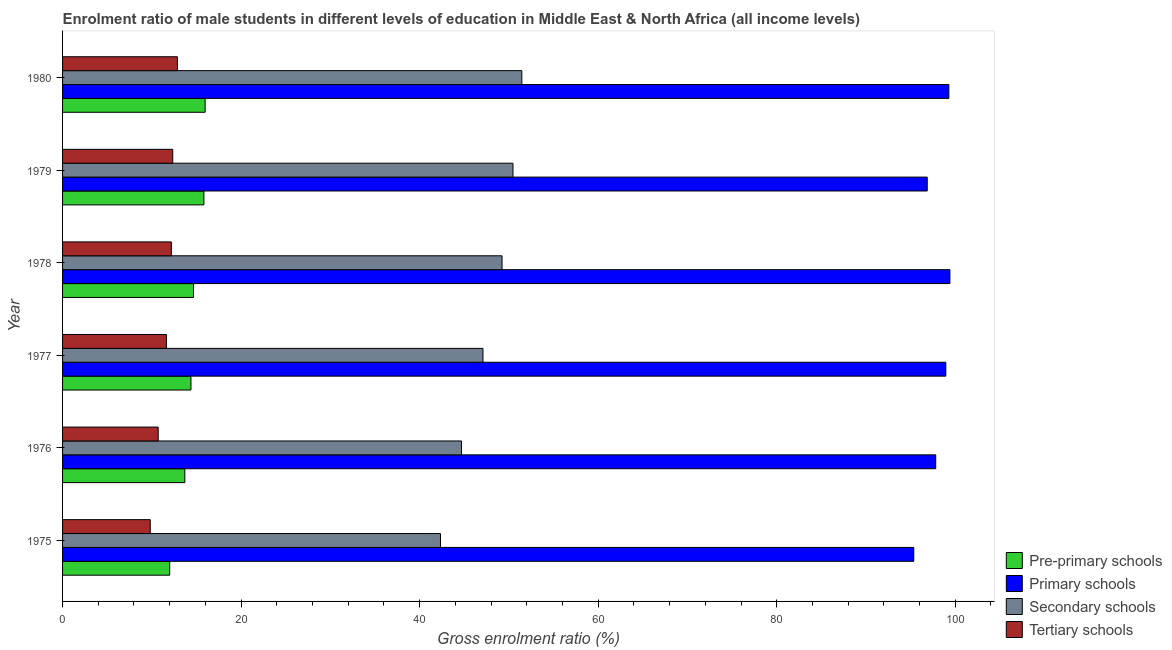How many groups of bars are there?
Ensure brevity in your answer.  6. How many bars are there on the 2nd tick from the bottom?
Offer a terse response. 4. What is the gross enrolment ratio(female) in secondary schools in 1975?
Offer a very short reply. 42.33. Across all years, what is the maximum gross enrolment ratio(female) in pre-primary schools?
Your response must be concise. 15.97. Across all years, what is the minimum gross enrolment ratio(female) in primary schools?
Your answer should be compact. 95.35. In which year was the gross enrolment ratio(female) in pre-primary schools maximum?
Your response must be concise. 1980. In which year was the gross enrolment ratio(female) in tertiary schools minimum?
Keep it short and to the point. 1975. What is the total gross enrolment ratio(female) in pre-primary schools in the graph?
Ensure brevity in your answer.  86.55. What is the difference between the gross enrolment ratio(female) in primary schools in 1977 and that in 1980?
Offer a very short reply. -0.34. What is the difference between the gross enrolment ratio(female) in pre-primary schools in 1980 and the gross enrolment ratio(female) in tertiary schools in 1977?
Keep it short and to the point. 4.34. What is the average gross enrolment ratio(female) in tertiary schools per year?
Your response must be concise. 11.59. In the year 1979, what is the difference between the gross enrolment ratio(female) in primary schools and gross enrolment ratio(female) in pre-primary schools?
Your answer should be compact. 81.03. In how many years, is the gross enrolment ratio(female) in pre-primary schools greater than 28 %?
Provide a short and direct response. 0. What is the ratio of the gross enrolment ratio(female) in pre-primary schools in 1978 to that in 1980?
Give a very brief answer. 0.92. What is the difference between the highest and the second highest gross enrolment ratio(female) in primary schools?
Keep it short and to the point. 0.12. What is the difference between the highest and the lowest gross enrolment ratio(female) in pre-primary schools?
Your answer should be very brief. 3.97. Is the sum of the gross enrolment ratio(female) in tertiary schools in 1977 and 1979 greater than the maximum gross enrolment ratio(female) in pre-primary schools across all years?
Your response must be concise. Yes. Is it the case that in every year, the sum of the gross enrolment ratio(female) in pre-primary schools and gross enrolment ratio(female) in tertiary schools is greater than the sum of gross enrolment ratio(female) in primary schools and gross enrolment ratio(female) in secondary schools?
Your answer should be compact. No. What does the 1st bar from the top in 1975 represents?
Ensure brevity in your answer.  Tertiary schools. What does the 2nd bar from the bottom in 1978 represents?
Give a very brief answer. Primary schools. Is it the case that in every year, the sum of the gross enrolment ratio(female) in pre-primary schools and gross enrolment ratio(female) in primary schools is greater than the gross enrolment ratio(female) in secondary schools?
Ensure brevity in your answer.  Yes. Are the values on the major ticks of X-axis written in scientific E-notation?
Make the answer very short. No. Does the graph contain any zero values?
Give a very brief answer. No. Does the graph contain grids?
Provide a short and direct response. No. How are the legend labels stacked?
Provide a short and direct response. Vertical. What is the title of the graph?
Keep it short and to the point. Enrolment ratio of male students in different levels of education in Middle East & North Africa (all income levels). Does "Switzerland" appear as one of the legend labels in the graph?
Your answer should be compact. No. What is the label or title of the X-axis?
Ensure brevity in your answer.  Gross enrolment ratio (%). What is the label or title of the Y-axis?
Ensure brevity in your answer.  Year. What is the Gross enrolment ratio (%) of Pre-primary schools in 1975?
Your answer should be very brief. 12. What is the Gross enrolment ratio (%) in Primary schools in 1975?
Provide a short and direct response. 95.35. What is the Gross enrolment ratio (%) of Secondary schools in 1975?
Your answer should be very brief. 42.33. What is the Gross enrolment ratio (%) in Tertiary schools in 1975?
Ensure brevity in your answer.  9.82. What is the Gross enrolment ratio (%) of Pre-primary schools in 1976?
Your response must be concise. 13.69. What is the Gross enrolment ratio (%) of Primary schools in 1976?
Ensure brevity in your answer.  97.81. What is the Gross enrolment ratio (%) of Secondary schools in 1976?
Make the answer very short. 44.68. What is the Gross enrolment ratio (%) of Tertiary schools in 1976?
Ensure brevity in your answer.  10.71. What is the Gross enrolment ratio (%) of Pre-primary schools in 1977?
Your answer should be very brief. 14.38. What is the Gross enrolment ratio (%) of Primary schools in 1977?
Make the answer very short. 98.94. What is the Gross enrolment ratio (%) in Secondary schools in 1977?
Your response must be concise. 47.09. What is the Gross enrolment ratio (%) in Tertiary schools in 1977?
Give a very brief answer. 11.63. What is the Gross enrolment ratio (%) of Pre-primary schools in 1978?
Provide a short and direct response. 14.67. What is the Gross enrolment ratio (%) in Primary schools in 1978?
Your response must be concise. 99.4. What is the Gross enrolment ratio (%) in Secondary schools in 1978?
Provide a short and direct response. 49.23. What is the Gross enrolment ratio (%) in Tertiary schools in 1978?
Your response must be concise. 12.19. What is the Gross enrolment ratio (%) in Pre-primary schools in 1979?
Offer a very short reply. 15.83. What is the Gross enrolment ratio (%) of Primary schools in 1979?
Provide a short and direct response. 96.86. What is the Gross enrolment ratio (%) in Secondary schools in 1979?
Give a very brief answer. 50.45. What is the Gross enrolment ratio (%) of Tertiary schools in 1979?
Offer a very short reply. 12.34. What is the Gross enrolment ratio (%) in Pre-primary schools in 1980?
Make the answer very short. 15.97. What is the Gross enrolment ratio (%) in Primary schools in 1980?
Offer a very short reply. 99.28. What is the Gross enrolment ratio (%) of Secondary schools in 1980?
Provide a succinct answer. 51.45. What is the Gross enrolment ratio (%) of Tertiary schools in 1980?
Offer a very short reply. 12.86. Across all years, what is the maximum Gross enrolment ratio (%) of Pre-primary schools?
Ensure brevity in your answer.  15.97. Across all years, what is the maximum Gross enrolment ratio (%) of Primary schools?
Offer a very short reply. 99.4. Across all years, what is the maximum Gross enrolment ratio (%) in Secondary schools?
Your response must be concise. 51.45. Across all years, what is the maximum Gross enrolment ratio (%) in Tertiary schools?
Ensure brevity in your answer.  12.86. Across all years, what is the minimum Gross enrolment ratio (%) in Pre-primary schools?
Your response must be concise. 12. Across all years, what is the minimum Gross enrolment ratio (%) of Primary schools?
Your response must be concise. 95.35. Across all years, what is the minimum Gross enrolment ratio (%) of Secondary schools?
Provide a succinct answer. 42.33. Across all years, what is the minimum Gross enrolment ratio (%) in Tertiary schools?
Your response must be concise. 9.82. What is the total Gross enrolment ratio (%) of Pre-primary schools in the graph?
Your response must be concise. 86.55. What is the total Gross enrolment ratio (%) of Primary schools in the graph?
Keep it short and to the point. 587.64. What is the total Gross enrolment ratio (%) in Secondary schools in the graph?
Provide a succinct answer. 285.24. What is the total Gross enrolment ratio (%) in Tertiary schools in the graph?
Your response must be concise. 69.56. What is the difference between the Gross enrolment ratio (%) in Pre-primary schools in 1975 and that in 1976?
Your answer should be very brief. -1.69. What is the difference between the Gross enrolment ratio (%) of Primary schools in 1975 and that in 1976?
Your answer should be compact. -2.46. What is the difference between the Gross enrolment ratio (%) of Secondary schools in 1975 and that in 1976?
Your response must be concise. -2.35. What is the difference between the Gross enrolment ratio (%) in Tertiary schools in 1975 and that in 1976?
Provide a succinct answer. -0.89. What is the difference between the Gross enrolment ratio (%) in Pre-primary schools in 1975 and that in 1977?
Your answer should be compact. -2.38. What is the difference between the Gross enrolment ratio (%) in Primary schools in 1975 and that in 1977?
Provide a short and direct response. -3.59. What is the difference between the Gross enrolment ratio (%) of Secondary schools in 1975 and that in 1977?
Provide a succinct answer. -4.76. What is the difference between the Gross enrolment ratio (%) of Tertiary schools in 1975 and that in 1977?
Provide a short and direct response. -1.81. What is the difference between the Gross enrolment ratio (%) of Pre-primary schools in 1975 and that in 1978?
Provide a short and direct response. -2.67. What is the difference between the Gross enrolment ratio (%) of Primary schools in 1975 and that in 1978?
Make the answer very short. -4.05. What is the difference between the Gross enrolment ratio (%) in Secondary schools in 1975 and that in 1978?
Keep it short and to the point. -6.9. What is the difference between the Gross enrolment ratio (%) in Tertiary schools in 1975 and that in 1978?
Your response must be concise. -2.36. What is the difference between the Gross enrolment ratio (%) of Pre-primary schools in 1975 and that in 1979?
Keep it short and to the point. -3.83. What is the difference between the Gross enrolment ratio (%) in Primary schools in 1975 and that in 1979?
Offer a very short reply. -1.51. What is the difference between the Gross enrolment ratio (%) of Secondary schools in 1975 and that in 1979?
Your response must be concise. -8.12. What is the difference between the Gross enrolment ratio (%) in Tertiary schools in 1975 and that in 1979?
Provide a short and direct response. -2.52. What is the difference between the Gross enrolment ratio (%) of Pre-primary schools in 1975 and that in 1980?
Provide a succinct answer. -3.97. What is the difference between the Gross enrolment ratio (%) of Primary schools in 1975 and that in 1980?
Offer a terse response. -3.93. What is the difference between the Gross enrolment ratio (%) of Secondary schools in 1975 and that in 1980?
Provide a succinct answer. -9.11. What is the difference between the Gross enrolment ratio (%) of Tertiary schools in 1975 and that in 1980?
Your response must be concise. -3.04. What is the difference between the Gross enrolment ratio (%) of Pre-primary schools in 1976 and that in 1977?
Your answer should be very brief. -0.69. What is the difference between the Gross enrolment ratio (%) of Primary schools in 1976 and that in 1977?
Your answer should be compact. -1.13. What is the difference between the Gross enrolment ratio (%) of Secondary schools in 1976 and that in 1977?
Offer a very short reply. -2.41. What is the difference between the Gross enrolment ratio (%) of Tertiary schools in 1976 and that in 1977?
Your response must be concise. -0.92. What is the difference between the Gross enrolment ratio (%) in Pre-primary schools in 1976 and that in 1978?
Offer a terse response. -0.97. What is the difference between the Gross enrolment ratio (%) in Primary schools in 1976 and that in 1978?
Your response must be concise. -1.59. What is the difference between the Gross enrolment ratio (%) of Secondary schools in 1976 and that in 1978?
Your response must be concise. -4.54. What is the difference between the Gross enrolment ratio (%) of Tertiary schools in 1976 and that in 1978?
Your answer should be very brief. -1.47. What is the difference between the Gross enrolment ratio (%) in Pre-primary schools in 1976 and that in 1979?
Provide a short and direct response. -2.14. What is the difference between the Gross enrolment ratio (%) of Primary schools in 1976 and that in 1979?
Keep it short and to the point. 0.95. What is the difference between the Gross enrolment ratio (%) in Secondary schools in 1976 and that in 1979?
Offer a terse response. -5.77. What is the difference between the Gross enrolment ratio (%) of Tertiary schools in 1976 and that in 1979?
Ensure brevity in your answer.  -1.63. What is the difference between the Gross enrolment ratio (%) of Pre-primary schools in 1976 and that in 1980?
Your response must be concise. -2.28. What is the difference between the Gross enrolment ratio (%) of Primary schools in 1976 and that in 1980?
Your response must be concise. -1.47. What is the difference between the Gross enrolment ratio (%) in Secondary schools in 1976 and that in 1980?
Make the answer very short. -6.76. What is the difference between the Gross enrolment ratio (%) of Tertiary schools in 1976 and that in 1980?
Provide a short and direct response. -2.15. What is the difference between the Gross enrolment ratio (%) of Pre-primary schools in 1977 and that in 1978?
Provide a short and direct response. -0.29. What is the difference between the Gross enrolment ratio (%) of Primary schools in 1977 and that in 1978?
Your answer should be compact. -0.46. What is the difference between the Gross enrolment ratio (%) in Secondary schools in 1977 and that in 1978?
Your answer should be compact. -2.14. What is the difference between the Gross enrolment ratio (%) in Tertiary schools in 1977 and that in 1978?
Give a very brief answer. -0.56. What is the difference between the Gross enrolment ratio (%) in Pre-primary schools in 1977 and that in 1979?
Your answer should be compact. -1.45. What is the difference between the Gross enrolment ratio (%) in Primary schools in 1977 and that in 1979?
Offer a terse response. 2.08. What is the difference between the Gross enrolment ratio (%) of Secondary schools in 1977 and that in 1979?
Your answer should be very brief. -3.36. What is the difference between the Gross enrolment ratio (%) in Tertiary schools in 1977 and that in 1979?
Provide a short and direct response. -0.71. What is the difference between the Gross enrolment ratio (%) in Pre-primary schools in 1977 and that in 1980?
Provide a short and direct response. -1.59. What is the difference between the Gross enrolment ratio (%) of Primary schools in 1977 and that in 1980?
Ensure brevity in your answer.  -0.34. What is the difference between the Gross enrolment ratio (%) in Secondary schools in 1977 and that in 1980?
Provide a succinct answer. -4.35. What is the difference between the Gross enrolment ratio (%) in Tertiary schools in 1977 and that in 1980?
Your answer should be compact. -1.23. What is the difference between the Gross enrolment ratio (%) in Pre-primary schools in 1978 and that in 1979?
Your answer should be compact. -1.16. What is the difference between the Gross enrolment ratio (%) in Primary schools in 1978 and that in 1979?
Offer a terse response. 2.54. What is the difference between the Gross enrolment ratio (%) of Secondary schools in 1978 and that in 1979?
Provide a succinct answer. -1.22. What is the difference between the Gross enrolment ratio (%) in Tertiary schools in 1978 and that in 1979?
Ensure brevity in your answer.  -0.15. What is the difference between the Gross enrolment ratio (%) of Pre-primary schools in 1978 and that in 1980?
Your answer should be compact. -1.3. What is the difference between the Gross enrolment ratio (%) of Primary schools in 1978 and that in 1980?
Offer a terse response. 0.12. What is the difference between the Gross enrolment ratio (%) of Secondary schools in 1978 and that in 1980?
Make the answer very short. -2.22. What is the difference between the Gross enrolment ratio (%) of Tertiary schools in 1978 and that in 1980?
Ensure brevity in your answer.  -0.68. What is the difference between the Gross enrolment ratio (%) in Pre-primary schools in 1979 and that in 1980?
Offer a very short reply. -0.14. What is the difference between the Gross enrolment ratio (%) of Primary schools in 1979 and that in 1980?
Offer a very short reply. -2.42. What is the difference between the Gross enrolment ratio (%) of Secondary schools in 1979 and that in 1980?
Make the answer very short. -0.99. What is the difference between the Gross enrolment ratio (%) in Tertiary schools in 1979 and that in 1980?
Provide a short and direct response. -0.52. What is the difference between the Gross enrolment ratio (%) in Pre-primary schools in 1975 and the Gross enrolment ratio (%) in Primary schools in 1976?
Your answer should be very brief. -85.81. What is the difference between the Gross enrolment ratio (%) in Pre-primary schools in 1975 and the Gross enrolment ratio (%) in Secondary schools in 1976?
Make the answer very short. -32.68. What is the difference between the Gross enrolment ratio (%) in Pre-primary schools in 1975 and the Gross enrolment ratio (%) in Tertiary schools in 1976?
Provide a short and direct response. 1.29. What is the difference between the Gross enrolment ratio (%) of Primary schools in 1975 and the Gross enrolment ratio (%) of Secondary schools in 1976?
Keep it short and to the point. 50.67. What is the difference between the Gross enrolment ratio (%) in Primary schools in 1975 and the Gross enrolment ratio (%) in Tertiary schools in 1976?
Offer a terse response. 84.64. What is the difference between the Gross enrolment ratio (%) of Secondary schools in 1975 and the Gross enrolment ratio (%) of Tertiary schools in 1976?
Offer a very short reply. 31.62. What is the difference between the Gross enrolment ratio (%) in Pre-primary schools in 1975 and the Gross enrolment ratio (%) in Primary schools in 1977?
Offer a terse response. -86.94. What is the difference between the Gross enrolment ratio (%) in Pre-primary schools in 1975 and the Gross enrolment ratio (%) in Secondary schools in 1977?
Keep it short and to the point. -35.09. What is the difference between the Gross enrolment ratio (%) in Pre-primary schools in 1975 and the Gross enrolment ratio (%) in Tertiary schools in 1977?
Offer a very short reply. 0.37. What is the difference between the Gross enrolment ratio (%) of Primary schools in 1975 and the Gross enrolment ratio (%) of Secondary schools in 1977?
Your answer should be very brief. 48.26. What is the difference between the Gross enrolment ratio (%) of Primary schools in 1975 and the Gross enrolment ratio (%) of Tertiary schools in 1977?
Provide a short and direct response. 83.72. What is the difference between the Gross enrolment ratio (%) of Secondary schools in 1975 and the Gross enrolment ratio (%) of Tertiary schools in 1977?
Provide a succinct answer. 30.7. What is the difference between the Gross enrolment ratio (%) in Pre-primary schools in 1975 and the Gross enrolment ratio (%) in Primary schools in 1978?
Keep it short and to the point. -87.4. What is the difference between the Gross enrolment ratio (%) in Pre-primary schools in 1975 and the Gross enrolment ratio (%) in Secondary schools in 1978?
Your response must be concise. -37.23. What is the difference between the Gross enrolment ratio (%) in Pre-primary schools in 1975 and the Gross enrolment ratio (%) in Tertiary schools in 1978?
Your answer should be very brief. -0.19. What is the difference between the Gross enrolment ratio (%) of Primary schools in 1975 and the Gross enrolment ratio (%) of Secondary schools in 1978?
Provide a short and direct response. 46.12. What is the difference between the Gross enrolment ratio (%) of Primary schools in 1975 and the Gross enrolment ratio (%) of Tertiary schools in 1978?
Provide a succinct answer. 83.16. What is the difference between the Gross enrolment ratio (%) in Secondary schools in 1975 and the Gross enrolment ratio (%) in Tertiary schools in 1978?
Offer a very short reply. 30.15. What is the difference between the Gross enrolment ratio (%) in Pre-primary schools in 1975 and the Gross enrolment ratio (%) in Primary schools in 1979?
Your answer should be very brief. -84.86. What is the difference between the Gross enrolment ratio (%) of Pre-primary schools in 1975 and the Gross enrolment ratio (%) of Secondary schools in 1979?
Give a very brief answer. -38.45. What is the difference between the Gross enrolment ratio (%) of Pre-primary schools in 1975 and the Gross enrolment ratio (%) of Tertiary schools in 1979?
Provide a short and direct response. -0.34. What is the difference between the Gross enrolment ratio (%) in Primary schools in 1975 and the Gross enrolment ratio (%) in Secondary schools in 1979?
Offer a terse response. 44.9. What is the difference between the Gross enrolment ratio (%) of Primary schools in 1975 and the Gross enrolment ratio (%) of Tertiary schools in 1979?
Offer a terse response. 83.01. What is the difference between the Gross enrolment ratio (%) in Secondary schools in 1975 and the Gross enrolment ratio (%) in Tertiary schools in 1979?
Provide a succinct answer. 29.99. What is the difference between the Gross enrolment ratio (%) in Pre-primary schools in 1975 and the Gross enrolment ratio (%) in Primary schools in 1980?
Provide a short and direct response. -87.28. What is the difference between the Gross enrolment ratio (%) of Pre-primary schools in 1975 and the Gross enrolment ratio (%) of Secondary schools in 1980?
Ensure brevity in your answer.  -39.44. What is the difference between the Gross enrolment ratio (%) of Pre-primary schools in 1975 and the Gross enrolment ratio (%) of Tertiary schools in 1980?
Keep it short and to the point. -0.86. What is the difference between the Gross enrolment ratio (%) of Primary schools in 1975 and the Gross enrolment ratio (%) of Secondary schools in 1980?
Ensure brevity in your answer.  43.9. What is the difference between the Gross enrolment ratio (%) in Primary schools in 1975 and the Gross enrolment ratio (%) in Tertiary schools in 1980?
Your answer should be very brief. 82.49. What is the difference between the Gross enrolment ratio (%) in Secondary schools in 1975 and the Gross enrolment ratio (%) in Tertiary schools in 1980?
Offer a terse response. 29.47. What is the difference between the Gross enrolment ratio (%) of Pre-primary schools in 1976 and the Gross enrolment ratio (%) of Primary schools in 1977?
Give a very brief answer. -85.25. What is the difference between the Gross enrolment ratio (%) in Pre-primary schools in 1976 and the Gross enrolment ratio (%) in Secondary schools in 1977?
Make the answer very short. -33.4. What is the difference between the Gross enrolment ratio (%) in Pre-primary schools in 1976 and the Gross enrolment ratio (%) in Tertiary schools in 1977?
Your response must be concise. 2.06. What is the difference between the Gross enrolment ratio (%) in Primary schools in 1976 and the Gross enrolment ratio (%) in Secondary schools in 1977?
Provide a short and direct response. 50.72. What is the difference between the Gross enrolment ratio (%) in Primary schools in 1976 and the Gross enrolment ratio (%) in Tertiary schools in 1977?
Offer a terse response. 86.18. What is the difference between the Gross enrolment ratio (%) of Secondary schools in 1976 and the Gross enrolment ratio (%) of Tertiary schools in 1977?
Your answer should be very brief. 33.05. What is the difference between the Gross enrolment ratio (%) of Pre-primary schools in 1976 and the Gross enrolment ratio (%) of Primary schools in 1978?
Provide a succinct answer. -85.71. What is the difference between the Gross enrolment ratio (%) in Pre-primary schools in 1976 and the Gross enrolment ratio (%) in Secondary schools in 1978?
Ensure brevity in your answer.  -35.54. What is the difference between the Gross enrolment ratio (%) in Pre-primary schools in 1976 and the Gross enrolment ratio (%) in Tertiary schools in 1978?
Your answer should be compact. 1.51. What is the difference between the Gross enrolment ratio (%) of Primary schools in 1976 and the Gross enrolment ratio (%) of Secondary schools in 1978?
Your response must be concise. 48.58. What is the difference between the Gross enrolment ratio (%) of Primary schools in 1976 and the Gross enrolment ratio (%) of Tertiary schools in 1978?
Ensure brevity in your answer.  85.62. What is the difference between the Gross enrolment ratio (%) in Secondary schools in 1976 and the Gross enrolment ratio (%) in Tertiary schools in 1978?
Your response must be concise. 32.5. What is the difference between the Gross enrolment ratio (%) of Pre-primary schools in 1976 and the Gross enrolment ratio (%) of Primary schools in 1979?
Give a very brief answer. -83.17. What is the difference between the Gross enrolment ratio (%) in Pre-primary schools in 1976 and the Gross enrolment ratio (%) in Secondary schools in 1979?
Offer a terse response. -36.76. What is the difference between the Gross enrolment ratio (%) of Pre-primary schools in 1976 and the Gross enrolment ratio (%) of Tertiary schools in 1979?
Ensure brevity in your answer.  1.35. What is the difference between the Gross enrolment ratio (%) in Primary schools in 1976 and the Gross enrolment ratio (%) in Secondary schools in 1979?
Make the answer very short. 47.36. What is the difference between the Gross enrolment ratio (%) in Primary schools in 1976 and the Gross enrolment ratio (%) in Tertiary schools in 1979?
Make the answer very short. 85.47. What is the difference between the Gross enrolment ratio (%) of Secondary schools in 1976 and the Gross enrolment ratio (%) of Tertiary schools in 1979?
Give a very brief answer. 32.34. What is the difference between the Gross enrolment ratio (%) in Pre-primary schools in 1976 and the Gross enrolment ratio (%) in Primary schools in 1980?
Your answer should be very brief. -85.59. What is the difference between the Gross enrolment ratio (%) in Pre-primary schools in 1976 and the Gross enrolment ratio (%) in Secondary schools in 1980?
Provide a succinct answer. -37.75. What is the difference between the Gross enrolment ratio (%) of Pre-primary schools in 1976 and the Gross enrolment ratio (%) of Tertiary schools in 1980?
Offer a very short reply. 0.83. What is the difference between the Gross enrolment ratio (%) of Primary schools in 1976 and the Gross enrolment ratio (%) of Secondary schools in 1980?
Keep it short and to the point. 46.36. What is the difference between the Gross enrolment ratio (%) in Primary schools in 1976 and the Gross enrolment ratio (%) in Tertiary schools in 1980?
Ensure brevity in your answer.  84.95. What is the difference between the Gross enrolment ratio (%) of Secondary schools in 1976 and the Gross enrolment ratio (%) of Tertiary schools in 1980?
Your answer should be compact. 31.82. What is the difference between the Gross enrolment ratio (%) in Pre-primary schools in 1977 and the Gross enrolment ratio (%) in Primary schools in 1978?
Your answer should be compact. -85.02. What is the difference between the Gross enrolment ratio (%) of Pre-primary schools in 1977 and the Gross enrolment ratio (%) of Secondary schools in 1978?
Keep it short and to the point. -34.85. What is the difference between the Gross enrolment ratio (%) in Pre-primary schools in 1977 and the Gross enrolment ratio (%) in Tertiary schools in 1978?
Keep it short and to the point. 2.19. What is the difference between the Gross enrolment ratio (%) of Primary schools in 1977 and the Gross enrolment ratio (%) of Secondary schools in 1978?
Ensure brevity in your answer.  49.71. What is the difference between the Gross enrolment ratio (%) of Primary schools in 1977 and the Gross enrolment ratio (%) of Tertiary schools in 1978?
Provide a succinct answer. 86.75. What is the difference between the Gross enrolment ratio (%) of Secondary schools in 1977 and the Gross enrolment ratio (%) of Tertiary schools in 1978?
Ensure brevity in your answer.  34.9. What is the difference between the Gross enrolment ratio (%) of Pre-primary schools in 1977 and the Gross enrolment ratio (%) of Primary schools in 1979?
Keep it short and to the point. -82.48. What is the difference between the Gross enrolment ratio (%) of Pre-primary schools in 1977 and the Gross enrolment ratio (%) of Secondary schools in 1979?
Your response must be concise. -36.07. What is the difference between the Gross enrolment ratio (%) of Pre-primary schools in 1977 and the Gross enrolment ratio (%) of Tertiary schools in 1979?
Offer a very short reply. 2.04. What is the difference between the Gross enrolment ratio (%) in Primary schools in 1977 and the Gross enrolment ratio (%) in Secondary schools in 1979?
Make the answer very short. 48.49. What is the difference between the Gross enrolment ratio (%) in Primary schools in 1977 and the Gross enrolment ratio (%) in Tertiary schools in 1979?
Make the answer very short. 86.6. What is the difference between the Gross enrolment ratio (%) of Secondary schools in 1977 and the Gross enrolment ratio (%) of Tertiary schools in 1979?
Provide a short and direct response. 34.75. What is the difference between the Gross enrolment ratio (%) in Pre-primary schools in 1977 and the Gross enrolment ratio (%) in Primary schools in 1980?
Give a very brief answer. -84.9. What is the difference between the Gross enrolment ratio (%) of Pre-primary schools in 1977 and the Gross enrolment ratio (%) of Secondary schools in 1980?
Provide a succinct answer. -37.06. What is the difference between the Gross enrolment ratio (%) of Pre-primary schools in 1977 and the Gross enrolment ratio (%) of Tertiary schools in 1980?
Your response must be concise. 1.52. What is the difference between the Gross enrolment ratio (%) in Primary schools in 1977 and the Gross enrolment ratio (%) in Secondary schools in 1980?
Provide a short and direct response. 47.5. What is the difference between the Gross enrolment ratio (%) in Primary schools in 1977 and the Gross enrolment ratio (%) in Tertiary schools in 1980?
Make the answer very short. 86.08. What is the difference between the Gross enrolment ratio (%) of Secondary schools in 1977 and the Gross enrolment ratio (%) of Tertiary schools in 1980?
Ensure brevity in your answer.  34.23. What is the difference between the Gross enrolment ratio (%) in Pre-primary schools in 1978 and the Gross enrolment ratio (%) in Primary schools in 1979?
Give a very brief answer. -82.19. What is the difference between the Gross enrolment ratio (%) in Pre-primary schools in 1978 and the Gross enrolment ratio (%) in Secondary schools in 1979?
Provide a succinct answer. -35.78. What is the difference between the Gross enrolment ratio (%) of Pre-primary schools in 1978 and the Gross enrolment ratio (%) of Tertiary schools in 1979?
Ensure brevity in your answer.  2.33. What is the difference between the Gross enrolment ratio (%) of Primary schools in 1978 and the Gross enrolment ratio (%) of Secondary schools in 1979?
Your answer should be very brief. 48.95. What is the difference between the Gross enrolment ratio (%) of Primary schools in 1978 and the Gross enrolment ratio (%) of Tertiary schools in 1979?
Provide a succinct answer. 87.06. What is the difference between the Gross enrolment ratio (%) in Secondary schools in 1978 and the Gross enrolment ratio (%) in Tertiary schools in 1979?
Ensure brevity in your answer.  36.89. What is the difference between the Gross enrolment ratio (%) of Pre-primary schools in 1978 and the Gross enrolment ratio (%) of Primary schools in 1980?
Ensure brevity in your answer.  -84.61. What is the difference between the Gross enrolment ratio (%) in Pre-primary schools in 1978 and the Gross enrolment ratio (%) in Secondary schools in 1980?
Give a very brief answer. -36.78. What is the difference between the Gross enrolment ratio (%) in Pre-primary schools in 1978 and the Gross enrolment ratio (%) in Tertiary schools in 1980?
Make the answer very short. 1.81. What is the difference between the Gross enrolment ratio (%) in Primary schools in 1978 and the Gross enrolment ratio (%) in Secondary schools in 1980?
Give a very brief answer. 47.95. What is the difference between the Gross enrolment ratio (%) in Primary schools in 1978 and the Gross enrolment ratio (%) in Tertiary schools in 1980?
Your answer should be very brief. 86.54. What is the difference between the Gross enrolment ratio (%) in Secondary schools in 1978 and the Gross enrolment ratio (%) in Tertiary schools in 1980?
Offer a very short reply. 36.37. What is the difference between the Gross enrolment ratio (%) of Pre-primary schools in 1979 and the Gross enrolment ratio (%) of Primary schools in 1980?
Ensure brevity in your answer.  -83.45. What is the difference between the Gross enrolment ratio (%) in Pre-primary schools in 1979 and the Gross enrolment ratio (%) in Secondary schools in 1980?
Your answer should be compact. -35.61. What is the difference between the Gross enrolment ratio (%) in Pre-primary schools in 1979 and the Gross enrolment ratio (%) in Tertiary schools in 1980?
Provide a succinct answer. 2.97. What is the difference between the Gross enrolment ratio (%) of Primary schools in 1979 and the Gross enrolment ratio (%) of Secondary schools in 1980?
Provide a succinct answer. 45.41. What is the difference between the Gross enrolment ratio (%) of Primary schools in 1979 and the Gross enrolment ratio (%) of Tertiary schools in 1980?
Provide a short and direct response. 84. What is the difference between the Gross enrolment ratio (%) in Secondary schools in 1979 and the Gross enrolment ratio (%) in Tertiary schools in 1980?
Give a very brief answer. 37.59. What is the average Gross enrolment ratio (%) of Pre-primary schools per year?
Your answer should be very brief. 14.43. What is the average Gross enrolment ratio (%) of Primary schools per year?
Your response must be concise. 97.94. What is the average Gross enrolment ratio (%) in Secondary schools per year?
Provide a succinct answer. 47.54. What is the average Gross enrolment ratio (%) in Tertiary schools per year?
Offer a terse response. 11.59. In the year 1975, what is the difference between the Gross enrolment ratio (%) of Pre-primary schools and Gross enrolment ratio (%) of Primary schools?
Offer a terse response. -83.35. In the year 1975, what is the difference between the Gross enrolment ratio (%) in Pre-primary schools and Gross enrolment ratio (%) in Secondary schools?
Provide a succinct answer. -30.33. In the year 1975, what is the difference between the Gross enrolment ratio (%) of Pre-primary schools and Gross enrolment ratio (%) of Tertiary schools?
Provide a short and direct response. 2.18. In the year 1975, what is the difference between the Gross enrolment ratio (%) of Primary schools and Gross enrolment ratio (%) of Secondary schools?
Your answer should be very brief. 53.02. In the year 1975, what is the difference between the Gross enrolment ratio (%) in Primary schools and Gross enrolment ratio (%) in Tertiary schools?
Your answer should be compact. 85.53. In the year 1975, what is the difference between the Gross enrolment ratio (%) of Secondary schools and Gross enrolment ratio (%) of Tertiary schools?
Offer a very short reply. 32.51. In the year 1976, what is the difference between the Gross enrolment ratio (%) in Pre-primary schools and Gross enrolment ratio (%) in Primary schools?
Keep it short and to the point. -84.11. In the year 1976, what is the difference between the Gross enrolment ratio (%) in Pre-primary schools and Gross enrolment ratio (%) in Secondary schools?
Provide a short and direct response. -30.99. In the year 1976, what is the difference between the Gross enrolment ratio (%) in Pre-primary schools and Gross enrolment ratio (%) in Tertiary schools?
Ensure brevity in your answer.  2.98. In the year 1976, what is the difference between the Gross enrolment ratio (%) in Primary schools and Gross enrolment ratio (%) in Secondary schools?
Ensure brevity in your answer.  53.12. In the year 1976, what is the difference between the Gross enrolment ratio (%) in Primary schools and Gross enrolment ratio (%) in Tertiary schools?
Offer a terse response. 87.1. In the year 1976, what is the difference between the Gross enrolment ratio (%) in Secondary schools and Gross enrolment ratio (%) in Tertiary schools?
Provide a succinct answer. 33.97. In the year 1977, what is the difference between the Gross enrolment ratio (%) in Pre-primary schools and Gross enrolment ratio (%) in Primary schools?
Provide a succinct answer. -84.56. In the year 1977, what is the difference between the Gross enrolment ratio (%) of Pre-primary schools and Gross enrolment ratio (%) of Secondary schools?
Give a very brief answer. -32.71. In the year 1977, what is the difference between the Gross enrolment ratio (%) of Pre-primary schools and Gross enrolment ratio (%) of Tertiary schools?
Keep it short and to the point. 2.75. In the year 1977, what is the difference between the Gross enrolment ratio (%) of Primary schools and Gross enrolment ratio (%) of Secondary schools?
Ensure brevity in your answer.  51.85. In the year 1977, what is the difference between the Gross enrolment ratio (%) in Primary schools and Gross enrolment ratio (%) in Tertiary schools?
Keep it short and to the point. 87.31. In the year 1977, what is the difference between the Gross enrolment ratio (%) of Secondary schools and Gross enrolment ratio (%) of Tertiary schools?
Your response must be concise. 35.46. In the year 1978, what is the difference between the Gross enrolment ratio (%) of Pre-primary schools and Gross enrolment ratio (%) of Primary schools?
Offer a very short reply. -84.73. In the year 1978, what is the difference between the Gross enrolment ratio (%) in Pre-primary schools and Gross enrolment ratio (%) in Secondary schools?
Offer a very short reply. -34.56. In the year 1978, what is the difference between the Gross enrolment ratio (%) in Pre-primary schools and Gross enrolment ratio (%) in Tertiary schools?
Ensure brevity in your answer.  2.48. In the year 1978, what is the difference between the Gross enrolment ratio (%) of Primary schools and Gross enrolment ratio (%) of Secondary schools?
Offer a very short reply. 50.17. In the year 1978, what is the difference between the Gross enrolment ratio (%) in Primary schools and Gross enrolment ratio (%) in Tertiary schools?
Your response must be concise. 87.21. In the year 1978, what is the difference between the Gross enrolment ratio (%) in Secondary schools and Gross enrolment ratio (%) in Tertiary schools?
Keep it short and to the point. 37.04. In the year 1979, what is the difference between the Gross enrolment ratio (%) in Pre-primary schools and Gross enrolment ratio (%) in Primary schools?
Offer a very short reply. -81.03. In the year 1979, what is the difference between the Gross enrolment ratio (%) of Pre-primary schools and Gross enrolment ratio (%) of Secondary schools?
Make the answer very short. -34.62. In the year 1979, what is the difference between the Gross enrolment ratio (%) in Pre-primary schools and Gross enrolment ratio (%) in Tertiary schools?
Keep it short and to the point. 3.49. In the year 1979, what is the difference between the Gross enrolment ratio (%) of Primary schools and Gross enrolment ratio (%) of Secondary schools?
Keep it short and to the point. 46.41. In the year 1979, what is the difference between the Gross enrolment ratio (%) of Primary schools and Gross enrolment ratio (%) of Tertiary schools?
Make the answer very short. 84.52. In the year 1979, what is the difference between the Gross enrolment ratio (%) in Secondary schools and Gross enrolment ratio (%) in Tertiary schools?
Make the answer very short. 38.11. In the year 1980, what is the difference between the Gross enrolment ratio (%) of Pre-primary schools and Gross enrolment ratio (%) of Primary schools?
Your answer should be compact. -83.31. In the year 1980, what is the difference between the Gross enrolment ratio (%) in Pre-primary schools and Gross enrolment ratio (%) in Secondary schools?
Your answer should be compact. -35.47. In the year 1980, what is the difference between the Gross enrolment ratio (%) of Pre-primary schools and Gross enrolment ratio (%) of Tertiary schools?
Provide a succinct answer. 3.11. In the year 1980, what is the difference between the Gross enrolment ratio (%) of Primary schools and Gross enrolment ratio (%) of Secondary schools?
Provide a succinct answer. 47.83. In the year 1980, what is the difference between the Gross enrolment ratio (%) of Primary schools and Gross enrolment ratio (%) of Tertiary schools?
Your answer should be very brief. 86.42. In the year 1980, what is the difference between the Gross enrolment ratio (%) of Secondary schools and Gross enrolment ratio (%) of Tertiary schools?
Make the answer very short. 38.58. What is the ratio of the Gross enrolment ratio (%) in Pre-primary schools in 1975 to that in 1976?
Your response must be concise. 0.88. What is the ratio of the Gross enrolment ratio (%) in Primary schools in 1975 to that in 1976?
Offer a terse response. 0.97. What is the ratio of the Gross enrolment ratio (%) of Secondary schools in 1975 to that in 1976?
Your answer should be compact. 0.95. What is the ratio of the Gross enrolment ratio (%) in Tertiary schools in 1975 to that in 1976?
Give a very brief answer. 0.92. What is the ratio of the Gross enrolment ratio (%) in Pre-primary schools in 1975 to that in 1977?
Ensure brevity in your answer.  0.83. What is the ratio of the Gross enrolment ratio (%) of Primary schools in 1975 to that in 1977?
Offer a terse response. 0.96. What is the ratio of the Gross enrolment ratio (%) of Secondary schools in 1975 to that in 1977?
Your answer should be very brief. 0.9. What is the ratio of the Gross enrolment ratio (%) of Tertiary schools in 1975 to that in 1977?
Give a very brief answer. 0.84. What is the ratio of the Gross enrolment ratio (%) in Pre-primary schools in 1975 to that in 1978?
Provide a succinct answer. 0.82. What is the ratio of the Gross enrolment ratio (%) in Primary schools in 1975 to that in 1978?
Keep it short and to the point. 0.96. What is the ratio of the Gross enrolment ratio (%) in Secondary schools in 1975 to that in 1978?
Offer a terse response. 0.86. What is the ratio of the Gross enrolment ratio (%) in Tertiary schools in 1975 to that in 1978?
Your answer should be very brief. 0.81. What is the ratio of the Gross enrolment ratio (%) in Pre-primary schools in 1975 to that in 1979?
Your answer should be very brief. 0.76. What is the ratio of the Gross enrolment ratio (%) of Primary schools in 1975 to that in 1979?
Your response must be concise. 0.98. What is the ratio of the Gross enrolment ratio (%) of Secondary schools in 1975 to that in 1979?
Ensure brevity in your answer.  0.84. What is the ratio of the Gross enrolment ratio (%) of Tertiary schools in 1975 to that in 1979?
Provide a succinct answer. 0.8. What is the ratio of the Gross enrolment ratio (%) of Pre-primary schools in 1975 to that in 1980?
Offer a terse response. 0.75. What is the ratio of the Gross enrolment ratio (%) of Primary schools in 1975 to that in 1980?
Give a very brief answer. 0.96. What is the ratio of the Gross enrolment ratio (%) of Secondary schools in 1975 to that in 1980?
Provide a succinct answer. 0.82. What is the ratio of the Gross enrolment ratio (%) of Tertiary schools in 1975 to that in 1980?
Your answer should be compact. 0.76. What is the ratio of the Gross enrolment ratio (%) in Pre-primary schools in 1976 to that in 1977?
Your answer should be very brief. 0.95. What is the ratio of the Gross enrolment ratio (%) in Secondary schools in 1976 to that in 1977?
Your answer should be very brief. 0.95. What is the ratio of the Gross enrolment ratio (%) of Tertiary schools in 1976 to that in 1977?
Make the answer very short. 0.92. What is the ratio of the Gross enrolment ratio (%) of Pre-primary schools in 1976 to that in 1978?
Make the answer very short. 0.93. What is the ratio of the Gross enrolment ratio (%) in Primary schools in 1976 to that in 1978?
Provide a succinct answer. 0.98. What is the ratio of the Gross enrolment ratio (%) in Secondary schools in 1976 to that in 1978?
Your response must be concise. 0.91. What is the ratio of the Gross enrolment ratio (%) of Tertiary schools in 1976 to that in 1978?
Your response must be concise. 0.88. What is the ratio of the Gross enrolment ratio (%) in Pre-primary schools in 1976 to that in 1979?
Make the answer very short. 0.86. What is the ratio of the Gross enrolment ratio (%) of Primary schools in 1976 to that in 1979?
Provide a short and direct response. 1.01. What is the ratio of the Gross enrolment ratio (%) of Secondary schools in 1976 to that in 1979?
Give a very brief answer. 0.89. What is the ratio of the Gross enrolment ratio (%) in Tertiary schools in 1976 to that in 1979?
Give a very brief answer. 0.87. What is the ratio of the Gross enrolment ratio (%) of Pre-primary schools in 1976 to that in 1980?
Provide a succinct answer. 0.86. What is the ratio of the Gross enrolment ratio (%) in Primary schools in 1976 to that in 1980?
Your answer should be compact. 0.99. What is the ratio of the Gross enrolment ratio (%) in Secondary schools in 1976 to that in 1980?
Keep it short and to the point. 0.87. What is the ratio of the Gross enrolment ratio (%) in Tertiary schools in 1976 to that in 1980?
Provide a short and direct response. 0.83. What is the ratio of the Gross enrolment ratio (%) in Pre-primary schools in 1977 to that in 1978?
Your answer should be very brief. 0.98. What is the ratio of the Gross enrolment ratio (%) of Primary schools in 1977 to that in 1978?
Your response must be concise. 1. What is the ratio of the Gross enrolment ratio (%) in Secondary schools in 1977 to that in 1978?
Your answer should be very brief. 0.96. What is the ratio of the Gross enrolment ratio (%) of Tertiary schools in 1977 to that in 1978?
Ensure brevity in your answer.  0.95. What is the ratio of the Gross enrolment ratio (%) in Pre-primary schools in 1977 to that in 1979?
Keep it short and to the point. 0.91. What is the ratio of the Gross enrolment ratio (%) in Primary schools in 1977 to that in 1979?
Make the answer very short. 1.02. What is the ratio of the Gross enrolment ratio (%) of Secondary schools in 1977 to that in 1979?
Your answer should be compact. 0.93. What is the ratio of the Gross enrolment ratio (%) in Tertiary schools in 1977 to that in 1979?
Your response must be concise. 0.94. What is the ratio of the Gross enrolment ratio (%) in Pre-primary schools in 1977 to that in 1980?
Provide a succinct answer. 0.9. What is the ratio of the Gross enrolment ratio (%) in Primary schools in 1977 to that in 1980?
Provide a succinct answer. 1. What is the ratio of the Gross enrolment ratio (%) of Secondary schools in 1977 to that in 1980?
Your answer should be compact. 0.92. What is the ratio of the Gross enrolment ratio (%) in Tertiary schools in 1977 to that in 1980?
Your response must be concise. 0.9. What is the ratio of the Gross enrolment ratio (%) of Pre-primary schools in 1978 to that in 1979?
Ensure brevity in your answer.  0.93. What is the ratio of the Gross enrolment ratio (%) in Primary schools in 1978 to that in 1979?
Keep it short and to the point. 1.03. What is the ratio of the Gross enrolment ratio (%) in Secondary schools in 1978 to that in 1979?
Your answer should be compact. 0.98. What is the ratio of the Gross enrolment ratio (%) in Tertiary schools in 1978 to that in 1979?
Ensure brevity in your answer.  0.99. What is the ratio of the Gross enrolment ratio (%) in Pre-primary schools in 1978 to that in 1980?
Provide a succinct answer. 0.92. What is the ratio of the Gross enrolment ratio (%) of Secondary schools in 1978 to that in 1980?
Your answer should be very brief. 0.96. What is the ratio of the Gross enrolment ratio (%) of Tertiary schools in 1978 to that in 1980?
Provide a succinct answer. 0.95. What is the ratio of the Gross enrolment ratio (%) of Primary schools in 1979 to that in 1980?
Provide a succinct answer. 0.98. What is the ratio of the Gross enrolment ratio (%) in Secondary schools in 1979 to that in 1980?
Your answer should be very brief. 0.98. What is the ratio of the Gross enrolment ratio (%) in Tertiary schools in 1979 to that in 1980?
Provide a succinct answer. 0.96. What is the difference between the highest and the second highest Gross enrolment ratio (%) in Pre-primary schools?
Provide a succinct answer. 0.14. What is the difference between the highest and the second highest Gross enrolment ratio (%) in Primary schools?
Offer a terse response. 0.12. What is the difference between the highest and the second highest Gross enrolment ratio (%) in Tertiary schools?
Offer a very short reply. 0.52. What is the difference between the highest and the lowest Gross enrolment ratio (%) of Pre-primary schools?
Give a very brief answer. 3.97. What is the difference between the highest and the lowest Gross enrolment ratio (%) of Primary schools?
Ensure brevity in your answer.  4.05. What is the difference between the highest and the lowest Gross enrolment ratio (%) in Secondary schools?
Provide a succinct answer. 9.11. What is the difference between the highest and the lowest Gross enrolment ratio (%) of Tertiary schools?
Make the answer very short. 3.04. 